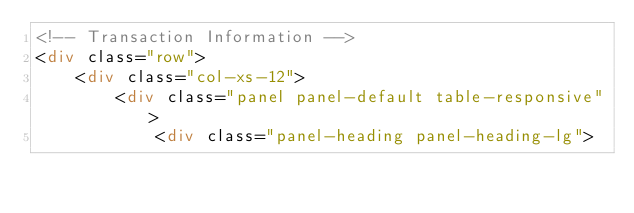Convert code to text. <code><loc_0><loc_0><loc_500><loc_500><_HTML_><!-- Transaction Information -->
<div class="row">
    <div class="col-xs-12">
        <div class="panel panel-default table-responsive">
            <div class="panel-heading panel-heading-lg"></code> 